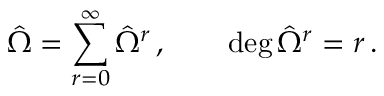Convert formula to latex. <formula><loc_0><loc_0><loc_500><loc_500>{ \hat { \Omega } } = \sum _ { r = 0 } ^ { \infty } { \hat { \Omega } } ^ { r } \, , \quad \deg { { \hat { \Omega } ^ { r } } } = r \, .</formula> 